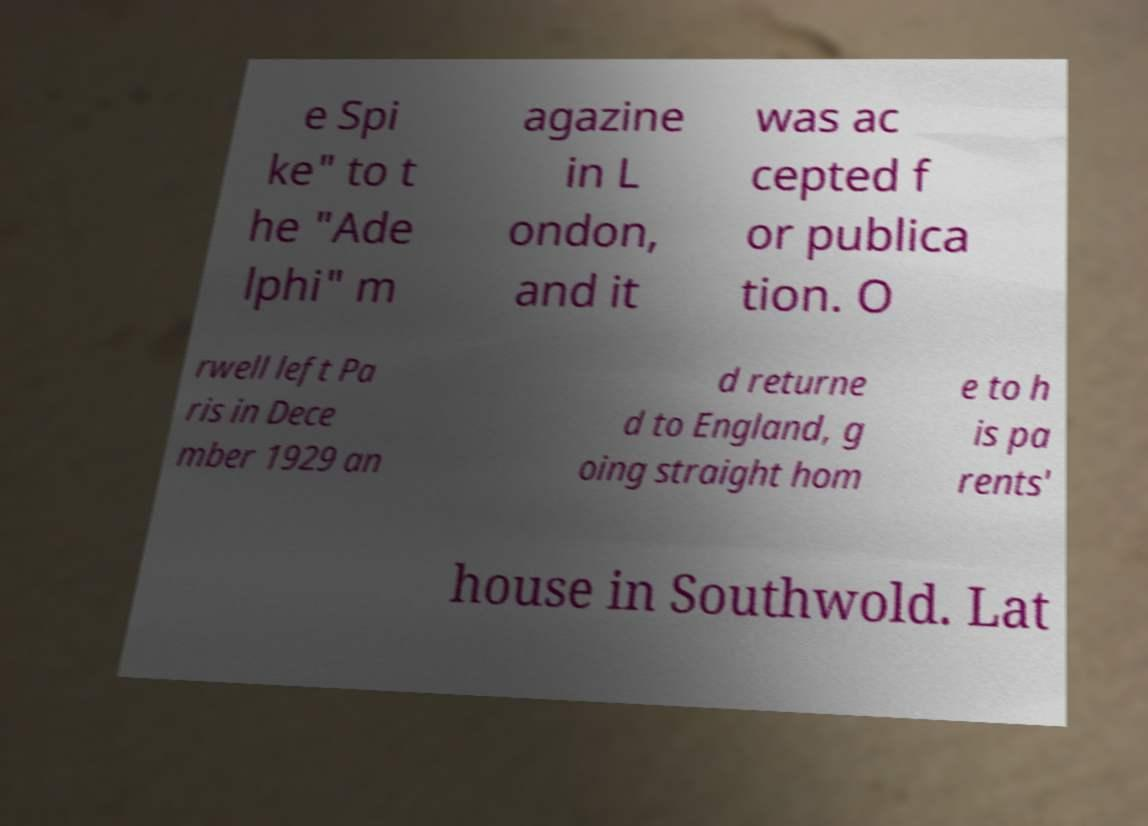Please read and relay the text visible in this image. What does it say? e Spi ke" to t he "Ade lphi" m agazine in L ondon, and it was ac cepted f or publica tion. O rwell left Pa ris in Dece mber 1929 an d returne d to England, g oing straight hom e to h is pa rents' house in Southwold. Lat 